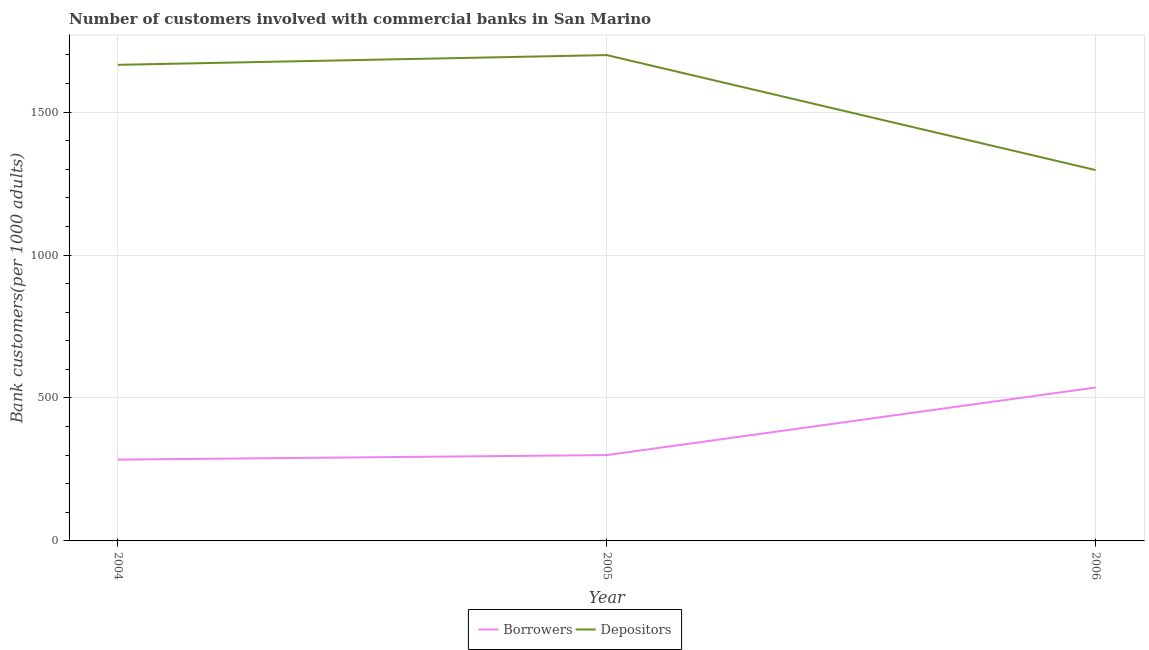Does the line corresponding to number of depositors intersect with the line corresponding to number of borrowers?
Ensure brevity in your answer.  No. What is the number of depositors in 2006?
Your response must be concise. 1297.22. Across all years, what is the maximum number of depositors?
Keep it short and to the point. 1699.33. Across all years, what is the minimum number of borrowers?
Your answer should be compact. 284.44. What is the total number of borrowers in the graph?
Your answer should be very brief. 1121.38. What is the difference between the number of borrowers in 2004 and that in 2006?
Your answer should be very brief. -252.25. What is the difference between the number of depositors in 2005 and the number of borrowers in 2006?
Make the answer very short. 1162.64. What is the average number of borrowers per year?
Your answer should be very brief. 373.79. In the year 2005, what is the difference between the number of depositors and number of borrowers?
Offer a very short reply. 1399.09. What is the ratio of the number of depositors in 2005 to that in 2006?
Your response must be concise. 1.31. Is the difference between the number of depositors in 2004 and 2006 greater than the difference between the number of borrowers in 2004 and 2006?
Make the answer very short. Yes. What is the difference between the highest and the second highest number of depositors?
Provide a short and direct response. 34.05. What is the difference between the highest and the lowest number of borrowers?
Your answer should be compact. 252.25. Is the sum of the number of borrowers in 2005 and 2006 greater than the maximum number of depositors across all years?
Offer a very short reply. No. Is the number of depositors strictly greater than the number of borrowers over the years?
Provide a short and direct response. Yes. How many lines are there?
Ensure brevity in your answer.  2. How many years are there in the graph?
Make the answer very short. 3. What is the difference between two consecutive major ticks on the Y-axis?
Your answer should be very brief. 500. Are the values on the major ticks of Y-axis written in scientific E-notation?
Keep it short and to the point. No. Does the graph contain any zero values?
Your answer should be compact. No. How are the legend labels stacked?
Ensure brevity in your answer.  Horizontal. What is the title of the graph?
Offer a terse response. Number of customers involved with commercial banks in San Marino. Does "Unregistered firms" appear as one of the legend labels in the graph?
Give a very brief answer. No. What is the label or title of the X-axis?
Offer a terse response. Year. What is the label or title of the Y-axis?
Offer a very short reply. Bank customers(per 1000 adults). What is the Bank customers(per 1000 adults) of Borrowers in 2004?
Give a very brief answer. 284.44. What is the Bank customers(per 1000 adults) in Depositors in 2004?
Your response must be concise. 1665.28. What is the Bank customers(per 1000 adults) in Borrowers in 2005?
Make the answer very short. 300.24. What is the Bank customers(per 1000 adults) in Depositors in 2005?
Provide a short and direct response. 1699.33. What is the Bank customers(per 1000 adults) in Borrowers in 2006?
Offer a very short reply. 536.69. What is the Bank customers(per 1000 adults) of Depositors in 2006?
Your response must be concise. 1297.22. Across all years, what is the maximum Bank customers(per 1000 adults) in Borrowers?
Offer a terse response. 536.69. Across all years, what is the maximum Bank customers(per 1000 adults) of Depositors?
Offer a very short reply. 1699.33. Across all years, what is the minimum Bank customers(per 1000 adults) in Borrowers?
Keep it short and to the point. 284.44. Across all years, what is the minimum Bank customers(per 1000 adults) in Depositors?
Ensure brevity in your answer.  1297.22. What is the total Bank customers(per 1000 adults) in Borrowers in the graph?
Make the answer very short. 1121.38. What is the total Bank customers(per 1000 adults) in Depositors in the graph?
Your answer should be very brief. 4661.84. What is the difference between the Bank customers(per 1000 adults) of Borrowers in 2004 and that in 2005?
Your answer should be compact. -15.8. What is the difference between the Bank customers(per 1000 adults) in Depositors in 2004 and that in 2005?
Offer a terse response. -34.05. What is the difference between the Bank customers(per 1000 adults) of Borrowers in 2004 and that in 2006?
Your response must be concise. -252.25. What is the difference between the Bank customers(per 1000 adults) of Depositors in 2004 and that in 2006?
Offer a terse response. 368.07. What is the difference between the Bank customers(per 1000 adults) in Borrowers in 2005 and that in 2006?
Your response must be concise. -236.45. What is the difference between the Bank customers(per 1000 adults) in Depositors in 2005 and that in 2006?
Your answer should be very brief. 402.12. What is the difference between the Bank customers(per 1000 adults) of Borrowers in 2004 and the Bank customers(per 1000 adults) of Depositors in 2005?
Offer a terse response. -1414.89. What is the difference between the Bank customers(per 1000 adults) of Borrowers in 2004 and the Bank customers(per 1000 adults) of Depositors in 2006?
Your answer should be very brief. -1012.77. What is the difference between the Bank customers(per 1000 adults) in Borrowers in 2005 and the Bank customers(per 1000 adults) in Depositors in 2006?
Your answer should be very brief. -996.97. What is the average Bank customers(per 1000 adults) in Borrowers per year?
Your answer should be compact. 373.79. What is the average Bank customers(per 1000 adults) in Depositors per year?
Ensure brevity in your answer.  1553.95. In the year 2004, what is the difference between the Bank customers(per 1000 adults) of Borrowers and Bank customers(per 1000 adults) of Depositors?
Provide a succinct answer. -1380.84. In the year 2005, what is the difference between the Bank customers(per 1000 adults) of Borrowers and Bank customers(per 1000 adults) of Depositors?
Provide a succinct answer. -1399.09. In the year 2006, what is the difference between the Bank customers(per 1000 adults) of Borrowers and Bank customers(per 1000 adults) of Depositors?
Ensure brevity in your answer.  -760.53. What is the ratio of the Bank customers(per 1000 adults) of Depositors in 2004 to that in 2005?
Provide a succinct answer. 0.98. What is the ratio of the Bank customers(per 1000 adults) in Borrowers in 2004 to that in 2006?
Offer a terse response. 0.53. What is the ratio of the Bank customers(per 1000 adults) in Depositors in 2004 to that in 2006?
Ensure brevity in your answer.  1.28. What is the ratio of the Bank customers(per 1000 adults) in Borrowers in 2005 to that in 2006?
Your answer should be very brief. 0.56. What is the ratio of the Bank customers(per 1000 adults) of Depositors in 2005 to that in 2006?
Provide a short and direct response. 1.31. What is the difference between the highest and the second highest Bank customers(per 1000 adults) of Borrowers?
Give a very brief answer. 236.45. What is the difference between the highest and the second highest Bank customers(per 1000 adults) of Depositors?
Your answer should be very brief. 34.05. What is the difference between the highest and the lowest Bank customers(per 1000 adults) of Borrowers?
Your answer should be very brief. 252.25. What is the difference between the highest and the lowest Bank customers(per 1000 adults) in Depositors?
Give a very brief answer. 402.12. 